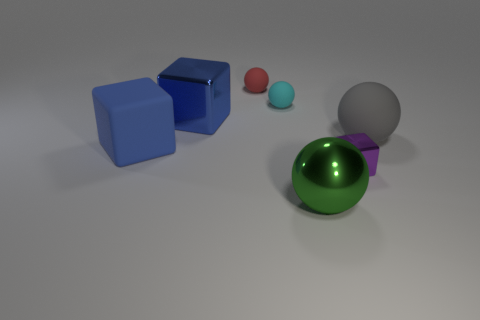There is a large blue metallic block that is behind the green metal sphere; what number of objects are behind it?
Give a very brief answer. 2. The tiny red matte object is what shape?
Ensure brevity in your answer.  Sphere. There is a blue object that is the same material as the small cyan sphere; what is its shape?
Make the answer very short. Cube. Is the shape of the big rubber thing that is on the right side of the blue rubber thing the same as  the green object?
Offer a terse response. Yes. There is a big object behind the big gray object; what shape is it?
Ensure brevity in your answer.  Cube. What is the shape of the rubber object that is the same color as the big shiny cube?
Give a very brief answer. Cube. What number of metal cubes are the same size as the green metallic ball?
Give a very brief answer. 1. What color is the large rubber ball?
Ensure brevity in your answer.  Gray. Is the color of the big metallic cube the same as the small thing that is in front of the gray rubber ball?
Make the answer very short. No. There is a gray thing that is the same material as the cyan object; what is its size?
Offer a very short reply. Large. 